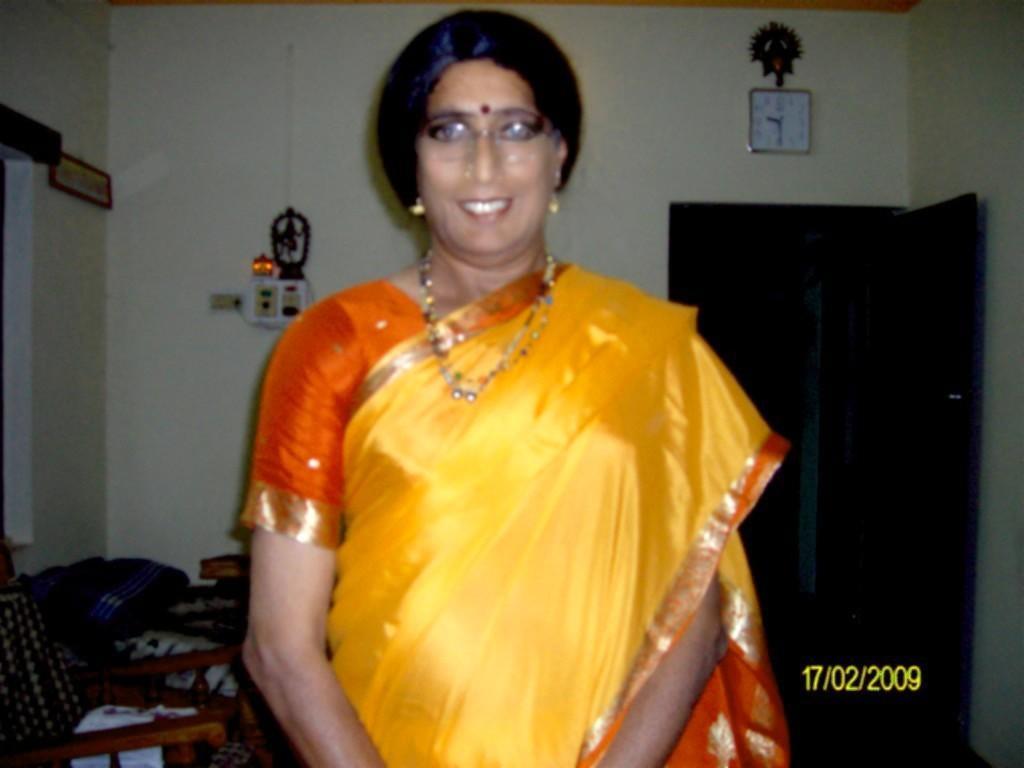In one or two sentences, can you explain what this image depicts? In this image we can see a woman standing. On the left side of the image we can see cloth and a bag placed on the chair. On the right side of the image we can see a door. In the background, we can see some objects on the wall. In the bottom right corner of this image we can see some numbers. 